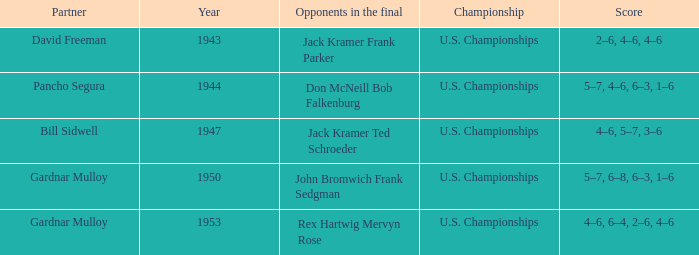Which Score has Opponents in the final of john bromwich frank sedgman? 5–7, 6–8, 6–3, 1–6. 